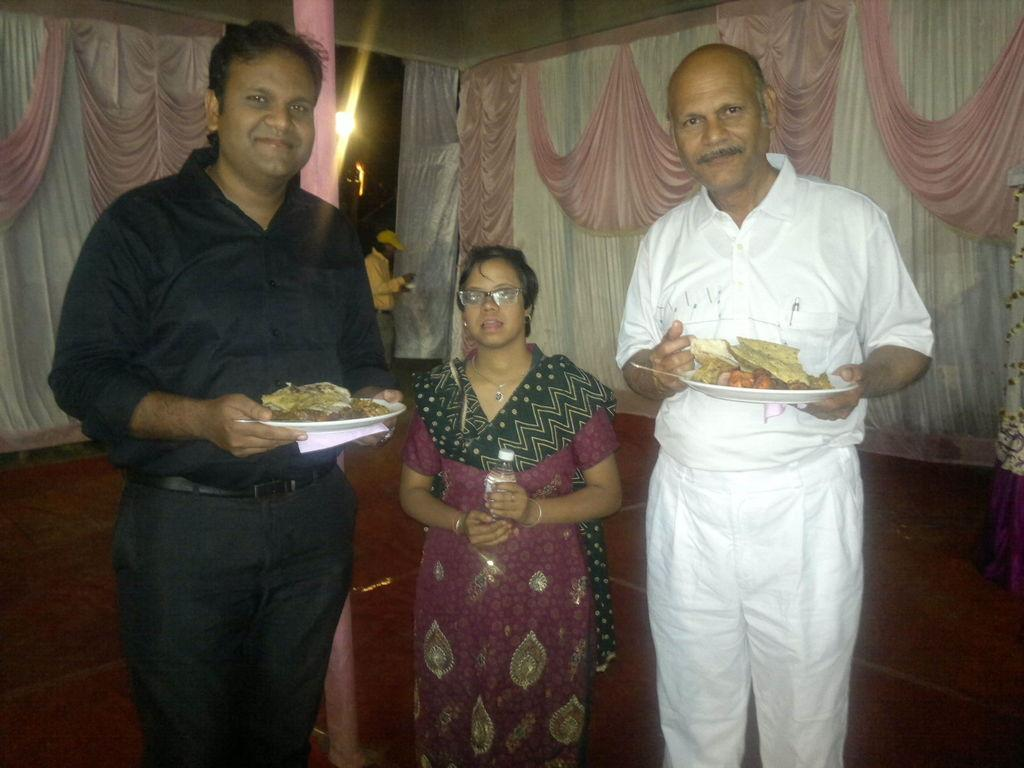How many persons are present in the image? There are persons in the image. What are two of the persons holding? Two persons are holding plates with food items. What is the woman holding? The woman is holding a bottle. What can be seen in the background of the image? There are curtains and light visible in the background of the image. What type of father can be seen in the image? There is no father present in the image. Is there a beggar visible in the image? There is no beggar present in the image. 